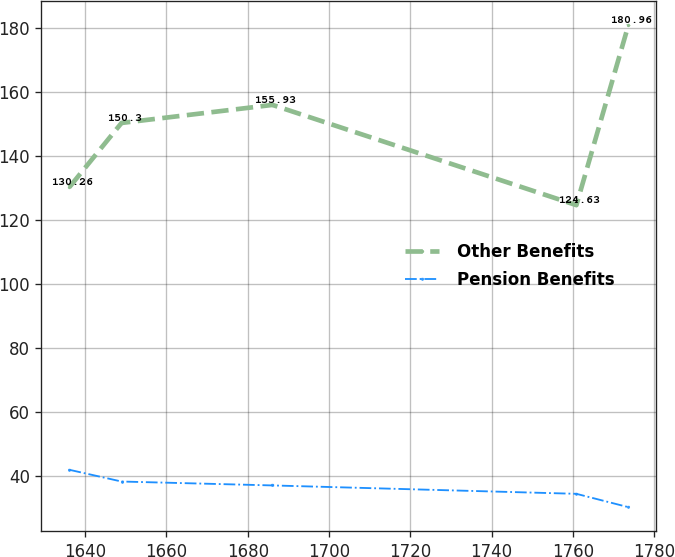<chart> <loc_0><loc_0><loc_500><loc_500><line_chart><ecel><fcel>Other Benefits<fcel>Pension Benefits<nl><fcel>1636.13<fcel>130.26<fcel>41.96<nl><fcel>1648.95<fcel>150.3<fcel>38.3<nl><fcel>1686.08<fcel>155.93<fcel>37.08<nl><fcel>1760.86<fcel>124.63<fcel>34.46<nl><fcel>1773.68<fcel>180.96<fcel>30.28<nl></chart> 